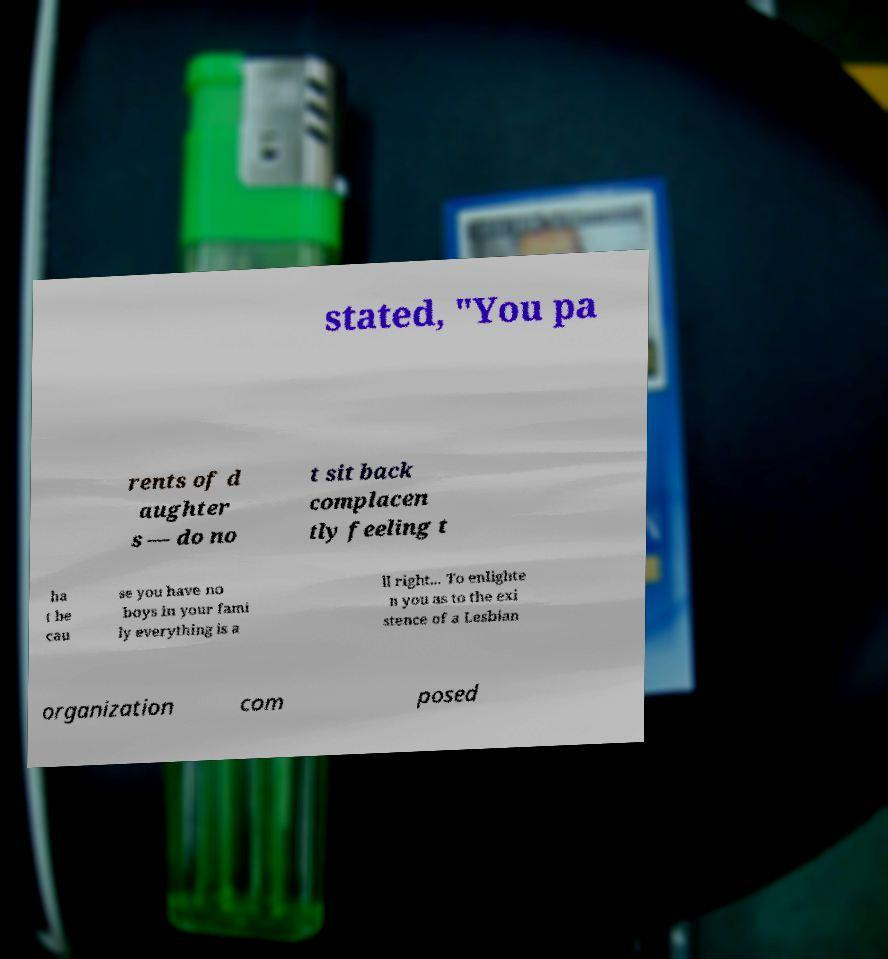Please identify and transcribe the text found in this image. stated, "You pa rents of d aughter s — do no t sit back complacen tly feeling t ha t be cau se you have no boys in your fami ly everything is a ll right... To enlighte n you as to the exi stence of a Lesbian organization com posed 